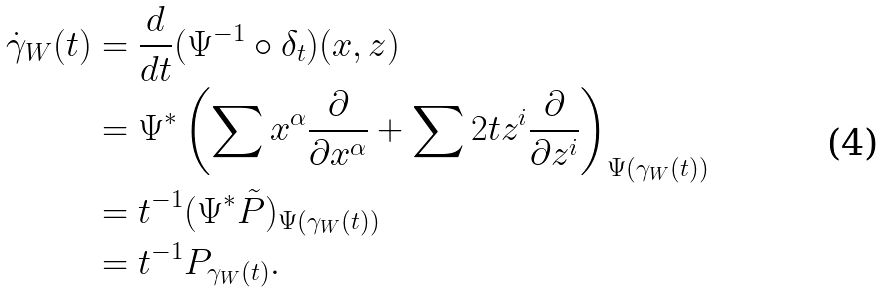<formula> <loc_0><loc_0><loc_500><loc_500>\dot { \gamma } _ { W } ( t ) & = \frac { d } { d t } ( \Psi ^ { - 1 } \circ \delta _ { t } ) ( x , z ) \\ & = \Psi ^ { * } \left ( \sum x ^ { \alpha } \frac { \partial } { \partial x ^ { \alpha } } + \sum 2 t z ^ { i } \frac { \partial } { \partial z ^ { i } } \right ) _ { \Psi ( \gamma _ { W } ( t ) ) } \\ & = t ^ { - 1 } ( \Psi ^ { * } \tilde { P } ) _ { \Psi ( \gamma _ { W } ( t ) ) } \\ & = t ^ { - 1 } P _ { \gamma _ { W } ( t ) } .</formula> 